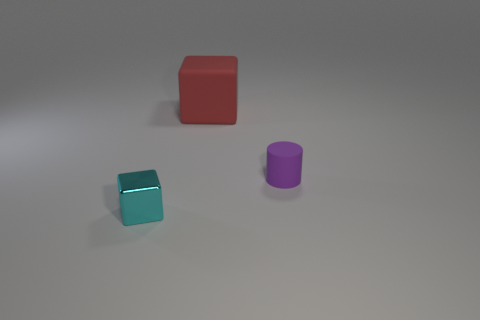Add 1 large purple cubes. How many objects exist? 4 Subtract all cylinders. How many objects are left? 2 Add 3 tiny purple rubber objects. How many tiny purple rubber objects are left? 4 Add 1 tiny matte objects. How many tiny matte objects exist? 2 Subtract 0 green balls. How many objects are left? 3 Subtract all cylinders. Subtract all small cylinders. How many objects are left? 1 